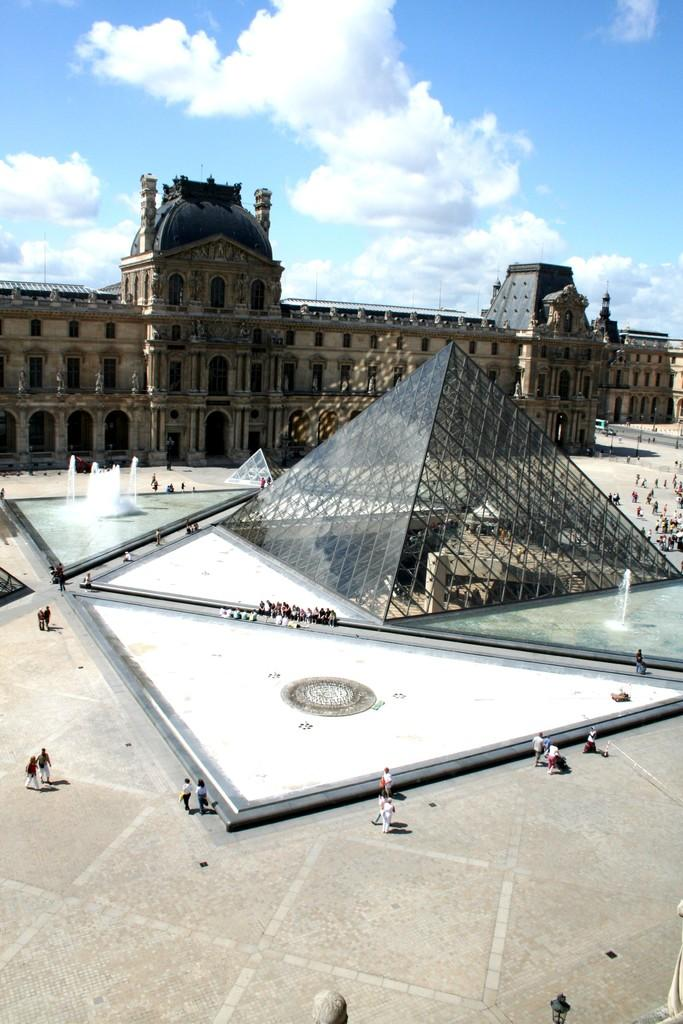What type of structures can be seen in the image? There are buildings in the image. What other features are present in the image? There are fountains, lights, a sculpture, and a glass pyramid in the image. Are there any people in the image? Yes, there are people in the image. What can be seen in the sky in the image? The sky is visible in the image. Where is the key located in the image? There is no key present in the image. What type of notebook is being used by the people in the image? There is no notebook present in the image. 